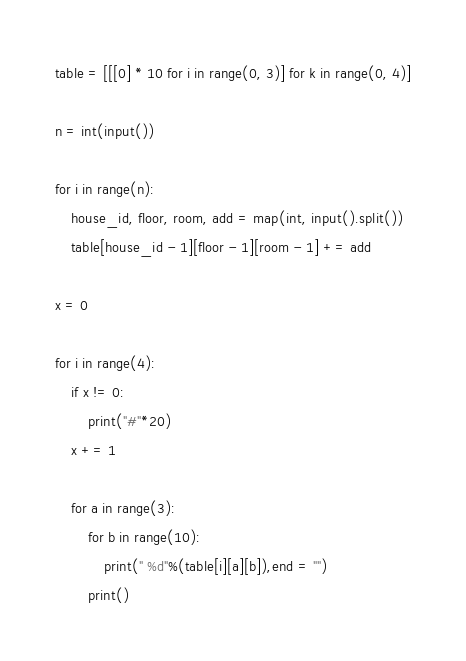<code> <loc_0><loc_0><loc_500><loc_500><_Python_>table = [[[0] * 10 for i in range(0, 3)] for k in range(0, 4)]

n = int(input())

for i in range(n):
    house_id, floor, room, add = map(int, input().split())
    table[house_id - 1][floor - 1][room - 1] += add

x = 0

for i in range(4):
    if x != 0:
        print("#"*20)
    x += 1

    for a in range(3):
        for b in range(10):
            print(" %d"%(table[i][a][b]),end = "")
        print()

</code> 